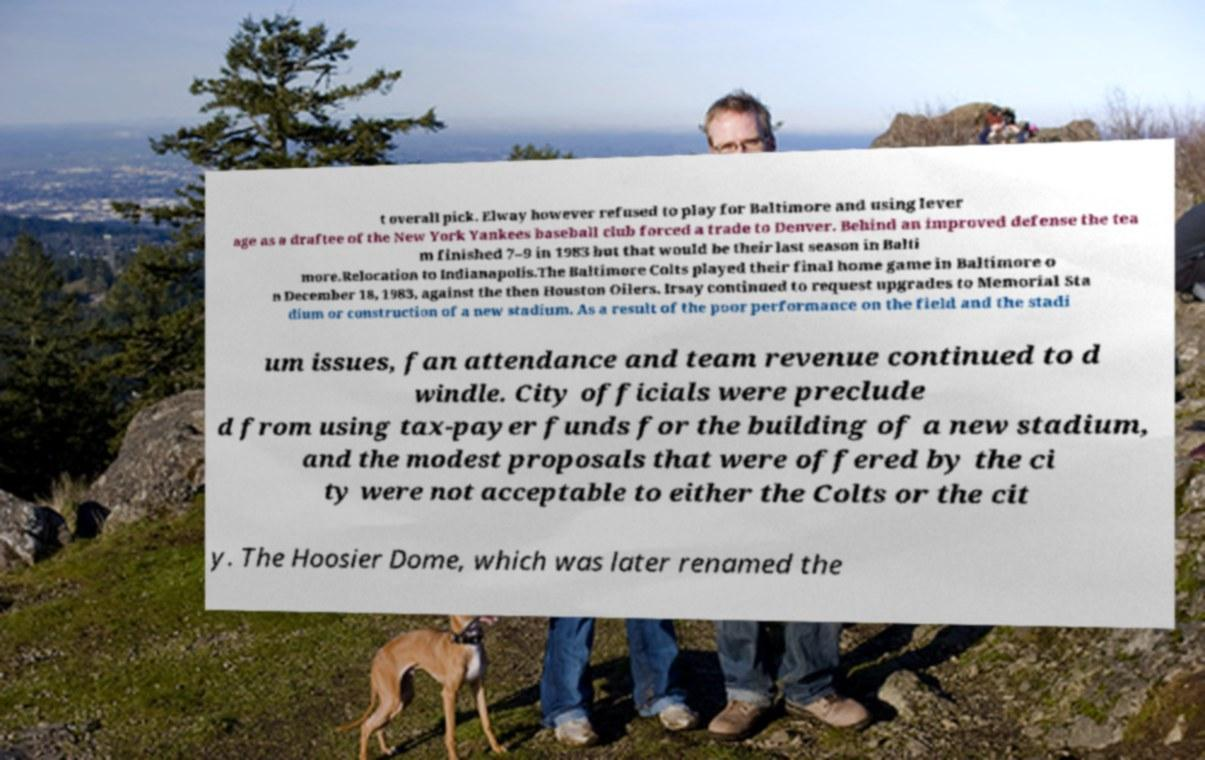There's text embedded in this image that I need extracted. Can you transcribe it verbatim? t overall pick. Elway however refused to play for Baltimore and using lever age as a draftee of the New York Yankees baseball club forced a trade to Denver. Behind an improved defense the tea m finished 7–9 in 1983 but that would be their last season in Balti more.Relocation to Indianapolis.The Baltimore Colts played their final home game in Baltimore o n December 18, 1983, against the then Houston Oilers. Irsay continued to request upgrades to Memorial Sta dium or construction of a new stadium. As a result of the poor performance on the field and the stadi um issues, fan attendance and team revenue continued to d windle. City officials were preclude d from using tax-payer funds for the building of a new stadium, and the modest proposals that were offered by the ci ty were not acceptable to either the Colts or the cit y. The Hoosier Dome, which was later renamed the 